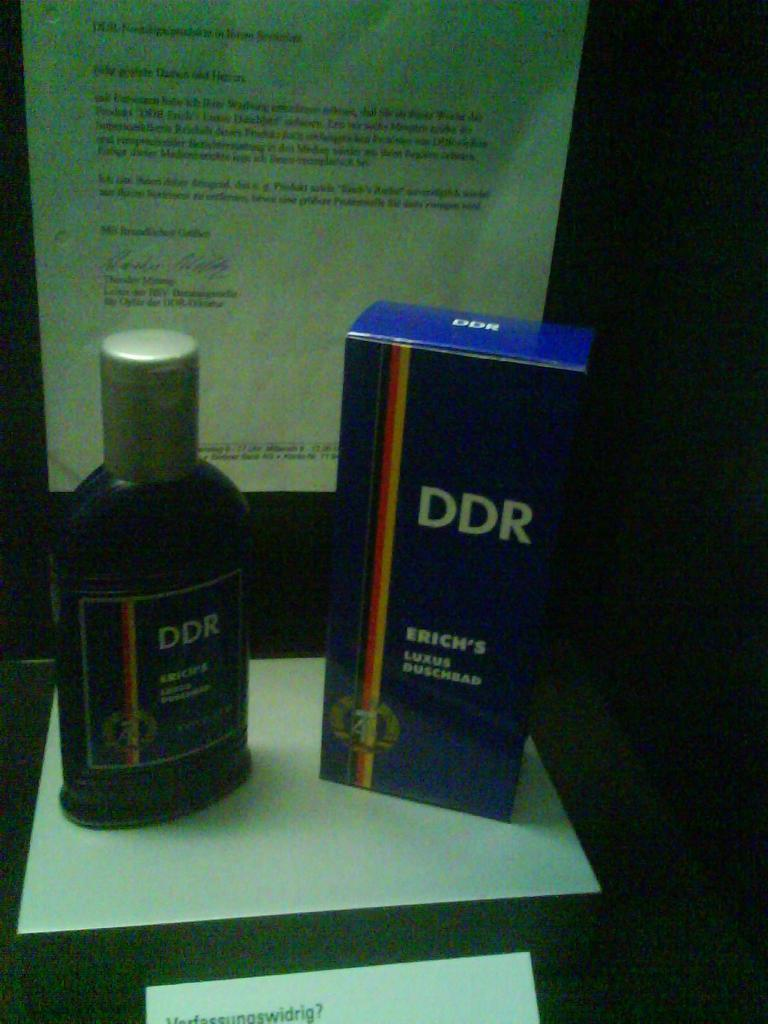<image>
Render a clear and concise summary of the photo. A display with a bottle of DDR and the matching box next to it 